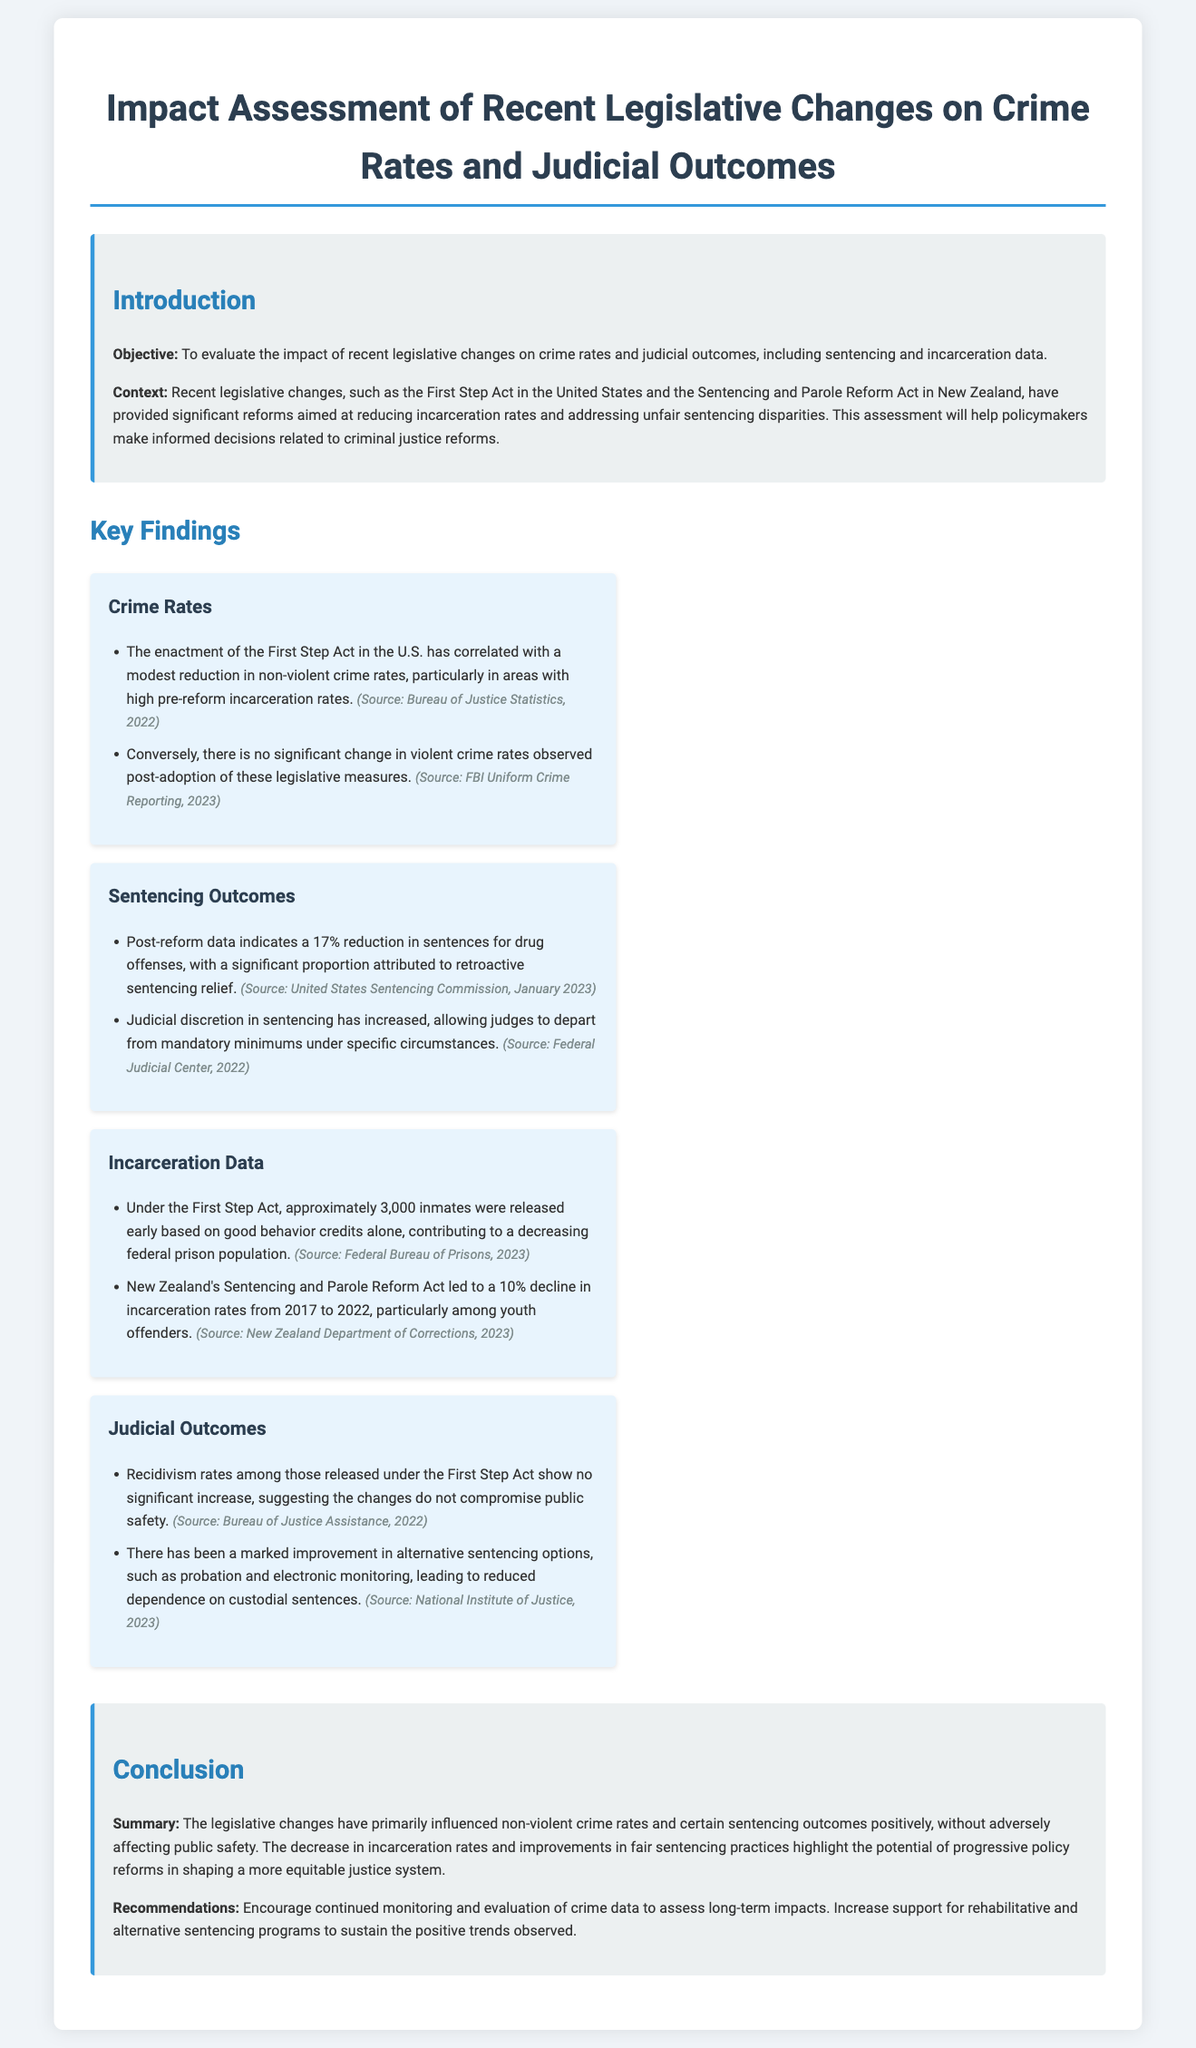What is the objective of the assessment? The objective is to evaluate the impact of recent legislative changes on crime rates and judicial outcomes.
Answer: To evaluate the impact of recent legislative changes on crime rates and judicial outcomes What percentage reduction in sentences for drug offenses was noted post-reform? The document states a 17% reduction in sentences for drug offenses post-reform.
Answer: 17% How many inmates were released early under the First Step Act? Approximately 3,000 inmates were released early based on good behavior credits.
Answer: 3,000 What was the decline in incarceration rates in New Zealand from 2017 to 2022? The document indicates a 10% decline in incarceration rates in New Zealand during that period.
Answer: 10% What is one recommendation from the conclusion? The recommendation includes increasing support for rehabilitative and alternative sentencing programs.
Answer: Increase support for rehabilitative and alternative sentencing programs What correlation was observed between the First Step Act and non-violent crime rates? The document mentions a modest reduction in non-violent crime rates correlated with the enactment of the First Step Act.
Answer: A modest reduction in non-violent crime rates What improvements were noted in judicial outcomes? There has been a marked improvement in alternative sentencing options like probation and electronic monitoring.
Answer: Marked improvement in alternative sentencing options What does the document suggest about public safety regarding individuals released under the First Step Act? The document states that recidivism rates among those released show no significant increase, indicating safety was not compromised.
Answer: No significant increase in recidivism rates 